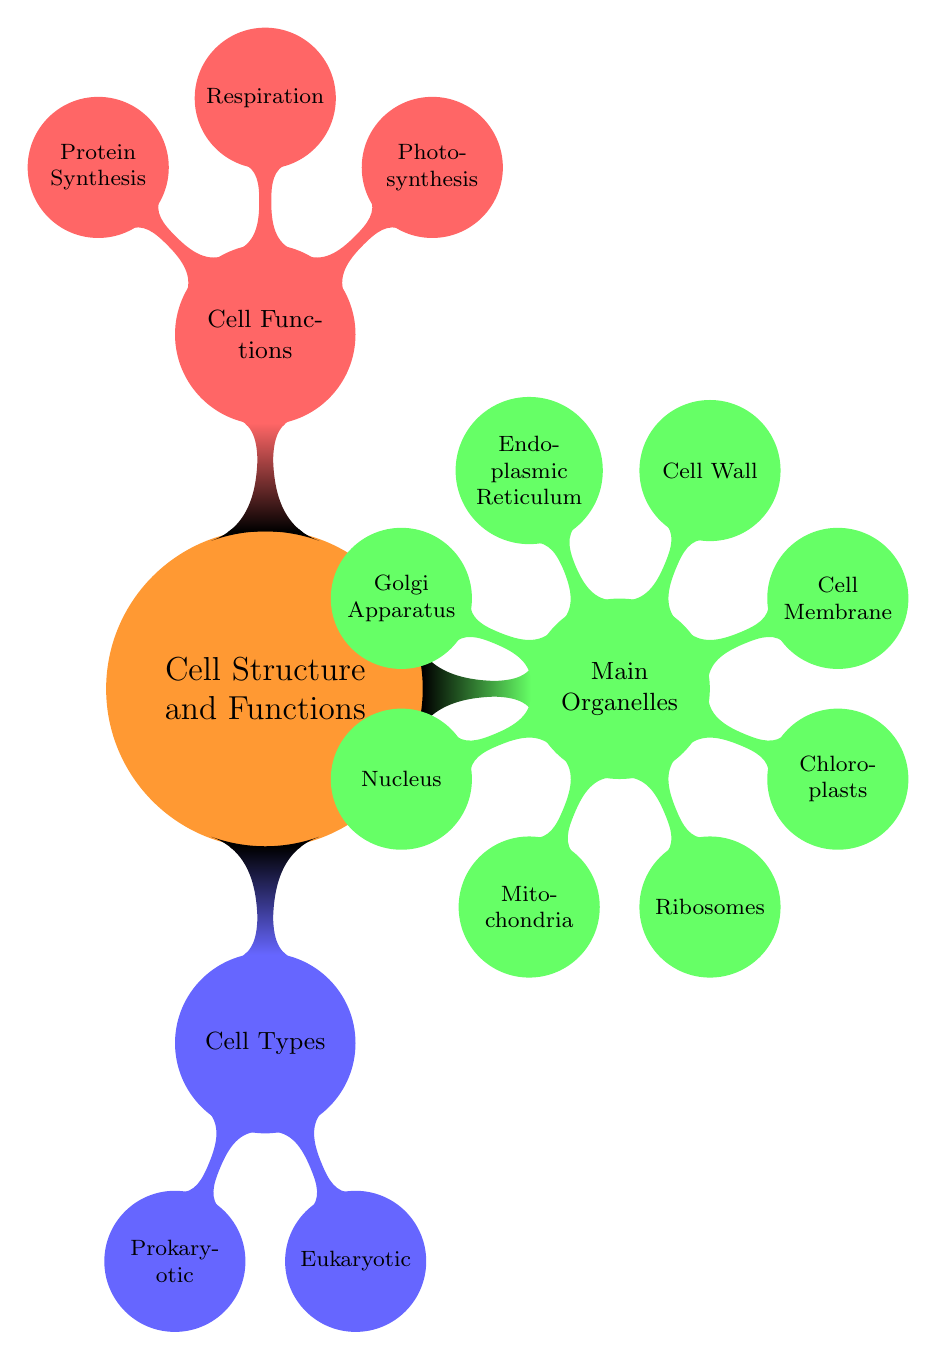What are the two types of cells shown? The diagram identifies two types of cells: Prokaryotic and Eukaryotic, which are listed under the "Cell Types" node.
Answer: Prokaryotic and Eukaryotic Which organelle is referred to as the "powerhouse of the cell"? According to the diagram, the Mitochondria are designated as the "powerhouse of the cell," which is stated under the "Main Organelles" section.
Answer: Mitochondria How many main organelles are included in the diagram? The diagram lists a total of eight main organelles under the "Main Organelles" node. The organelles include Nucleus, Mitochondria, Ribosomes, Chloroplasts, Cell Membrane, Cell Wall, Endoplasmic Reticulum, and Golgi Apparatus.
Answer: Eight Which organelle is responsible for photosynthesis? The "Cell Functions" section specifies that Chloroplasts are responsible for photosynthesis, and they are linked to the function description in that section.
Answer: Chloroplasts What function is associated with ribosomes? Ribosomes are assigned the function of Protein synthesis, as indicated in the "Main Organelles" section of the diagram.
Answer: Protein synthesis Which two organelles are found exclusively in Eukaryotic cells? The diagram indicates that both the Nucleus and Golgi Apparatus are only found in Eukaryotic cells, as specified in the "Found In" section for each of these organelles.
Answer: Nucleus and Golgi Apparatus What is the relationship between respiration and mitochondria? The diagram explicitly links respiration to mitochondria by stating that the mitochondria are the relevant organelle for the process of breaking down food to release energy.
Answer: Mitochondria Which cell types have a cell wall? The diagram notes that the Cell Wall is found in both Plant Cells and Bacteria, providing their classification under the "Found In" section for that organelle.
Answer: Plant Cells and Bacteria 